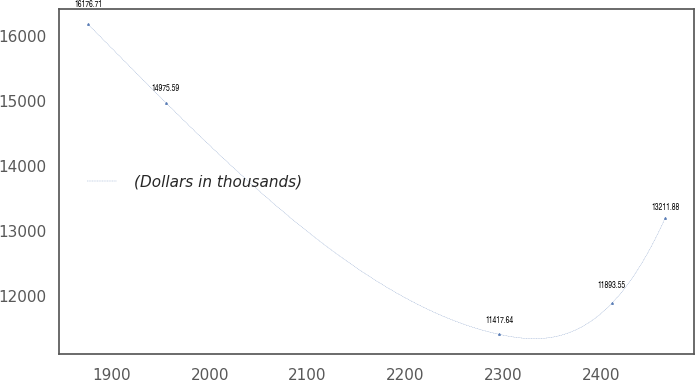Convert chart. <chart><loc_0><loc_0><loc_500><loc_500><line_chart><ecel><fcel>(Dollars in thousands)<nl><fcel>1875.99<fcel>16176.7<nl><fcel>1955.11<fcel>14975.6<nl><fcel>2295.89<fcel>11417.6<nl><fcel>2410.78<fcel>11893.5<nl><fcel>2465.63<fcel>13211.9<nl></chart> 